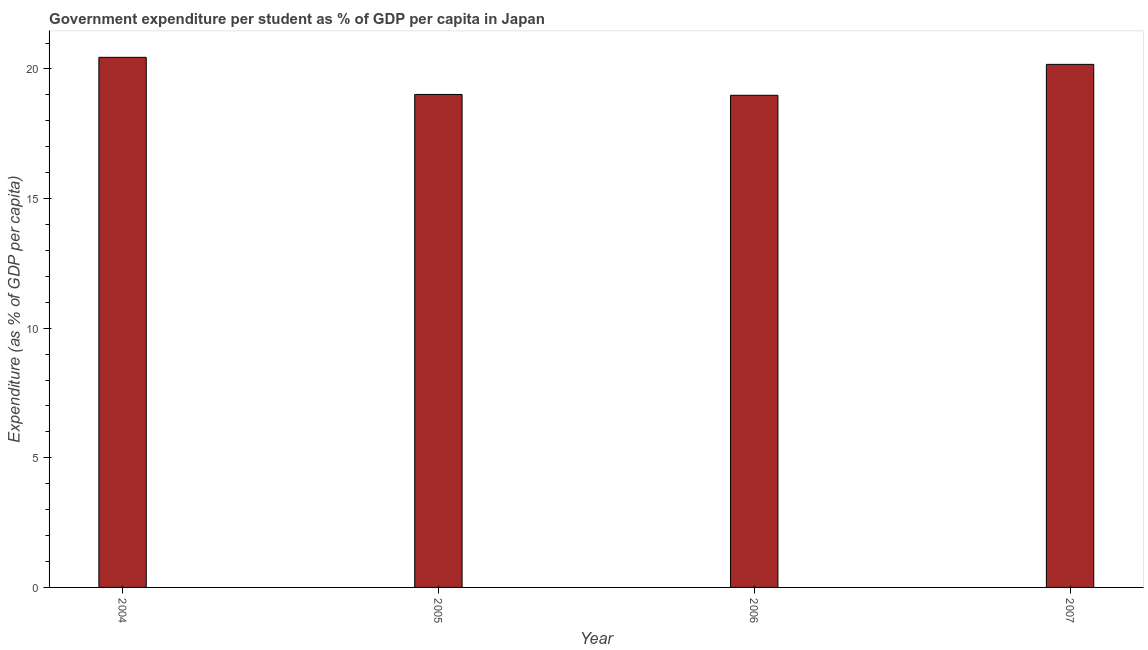Does the graph contain any zero values?
Give a very brief answer. No. What is the title of the graph?
Give a very brief answer. Government expenditure per student as % of GDP per capita in Japan. What is the label or title of the X-axis?
Offer a terse response. Year. What is the label or title of the Y-axis?
Your answer should be compact. Expenditure (as % of GDP per capita). What is the government expenditure per student in 2005?
Your answer should be compact. 19.02. Across all years, what is the maximum government expenditure per student?
Give a very brief answer. 20.45. Across all years, what is the minimum government expenditure per student?
Give a very brief answer. 18.98. In which year was the government expenditure per student maximum?
Your answer should be compact. 2004. What is the sum of the government expenditure per student?
Make the answer very short. 78.62. What is the difference between the government expenditure per student in 2005 and 2006?
Make the answer very short. 0.03. What is the average government expenditure per student per year?
Ensure brevity in your answer.  19.66. What is the median government expenditure per student?
Provide a succinct answer. 19.6. In how many years, is the government expenditure per student greater than 20 %?
Keep it short and to the point. 2. Do a majority of the years between 2006 and 2007 (inclusive) have government expenditure per student greater than 5 %?
Ensure brevity in your answer.  Yes. Is the government expenditure per student in 2006 less than that in 2007?
Your answer should be compact. Yes. What is the difference between the highest and the second highest government expenditure per student?
Provide a succinct answer. 0.27. What is the difference between the highest and the lowest government expenditure per student?
Offer a very short reply. 1.47. What is the difference between two consecutive major ticks on the Y-axis?
Make the answer very short. 5. Are the values on the major ticks of Y-axis written in scientific E-notation?
Provide a succinct answer. No. What is the Expenditure (as % of GDP per capita) of 2004?
Your response must be concise. 20.45. What is the Expenditure (as % of GDP per capita) of 2005?
Keep it short and to the point. 19.02. What is the Expenditure (as % of GDP per capita) in 2006?
Provide a short and direct response. 18.98. What is the Expenditure (as % of GDP per capita) in 2007?
Make the answer very short. 20.18. What is the difference between the Expenditure (as % of GDP per capita) in 2004 and 2005?
Provide a short and direct response. 1.43. What is the difference between the Expenditure (as % of GDP per capita) in 2004 and 2006?
Your answer should be compact. 1.47. What is the difference between the Expenditure (as % of GDP per capita) in 2004 and 2007?
Give a very brief answer. 0.27. What is the difference between the Expenditure (as % of GDP per capita) in 2005 and 2006?
Your answer should be very brief. 0.03. What is the difference between the Expenditure (as % of GDP per capita) in 2005 and 2007?
Your answer should be compact. -1.16. What is the difference between the Expenditure (as % of GDP per capita) in 2006 and 2007?
Make the answer very short. -1.19. What is the ratio of the Expenditure (as % of GDP per capita) in 2004 to that in 2005?
Make the answer very short. 1.07. What is the ratio of the Expenditure (as % of GDP per capita) in 2004 to that in 2006?
Make the answer very short. 1.08. What is the ratio of the Expenditure (as % of GDP per capita) in 2005 to that in 2007?
Offer a very short reply. 0.94. What is the ratio of the Expenditure (as % of GDP per capita) in 2006 to that in 2007?
Offer a terse response. 0.94. 